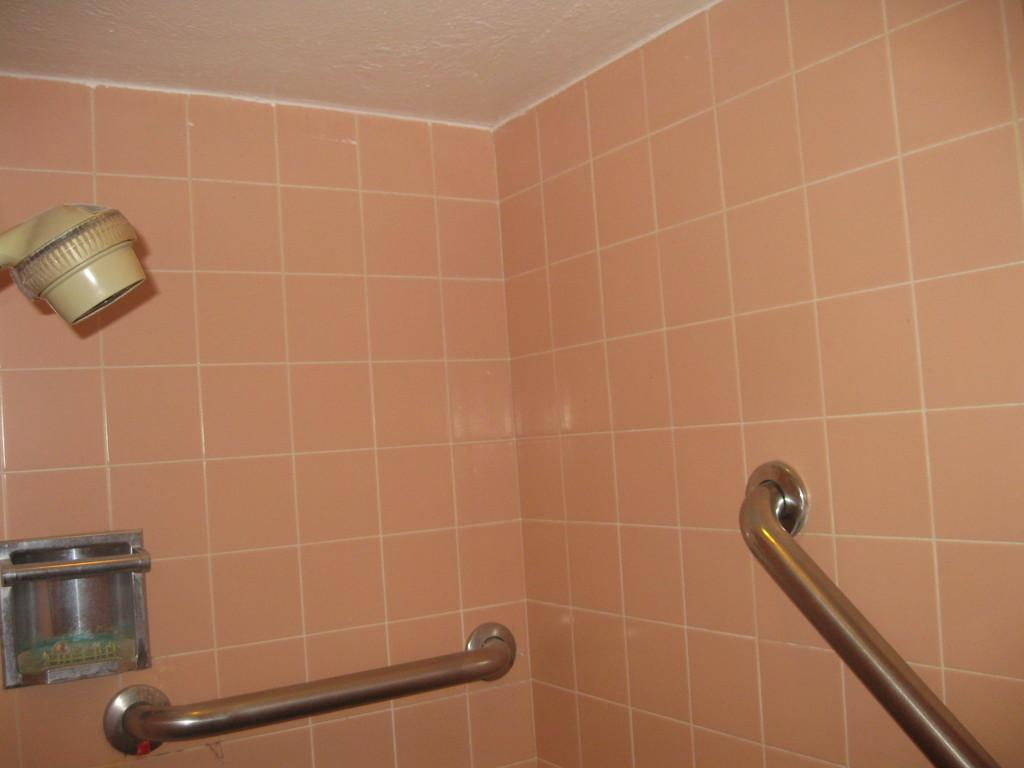What type of objects can be seen attached to the wall in the image? There are metal objects attached to the wall in the image. What type of roof can be seen on the structure in the image? There is no structure or roof present in the image; it only shows metal objects attached to the wall. 